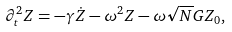Convert formula to latex. <formula><loc_0><loc_0><loc_500><loc_500>\partial _ { t } ^ { 2 } Z = - \gamma \dot { Z } - \omega ^ { 2 } Z - \omega \sqrt { N } G Z _ { 0 } ,</formula> 